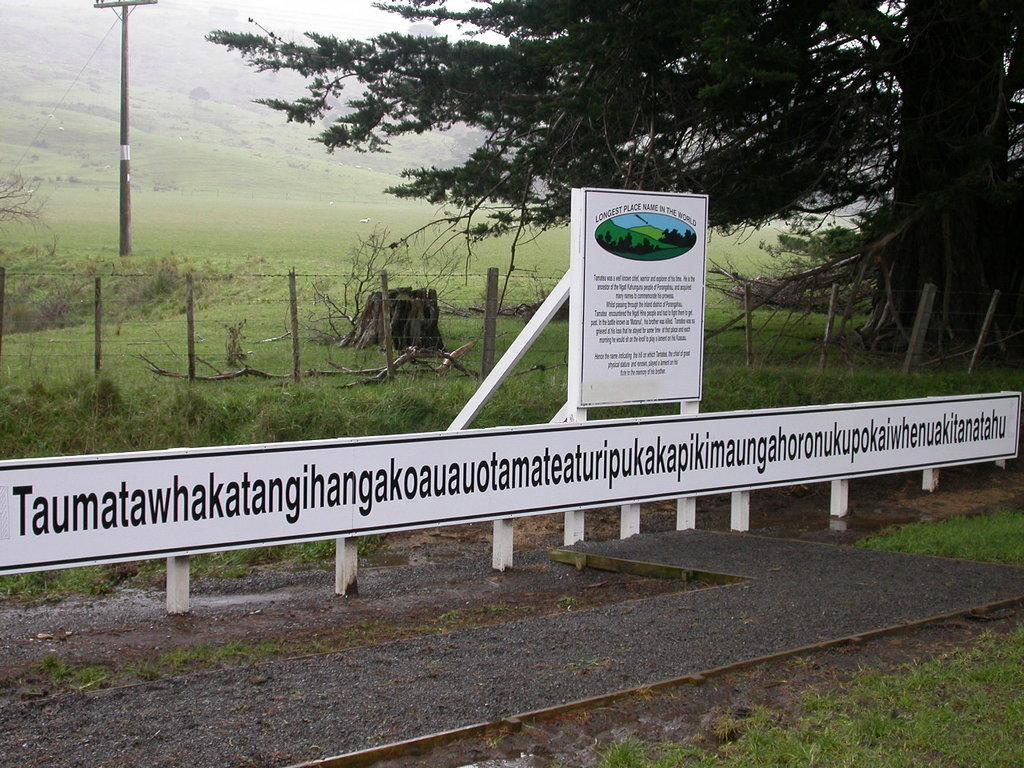How would you summarize this image in a sentence or two? In this picture we can see hoardings and we can find some text, in the background we can see few trees, grass and a pole. 